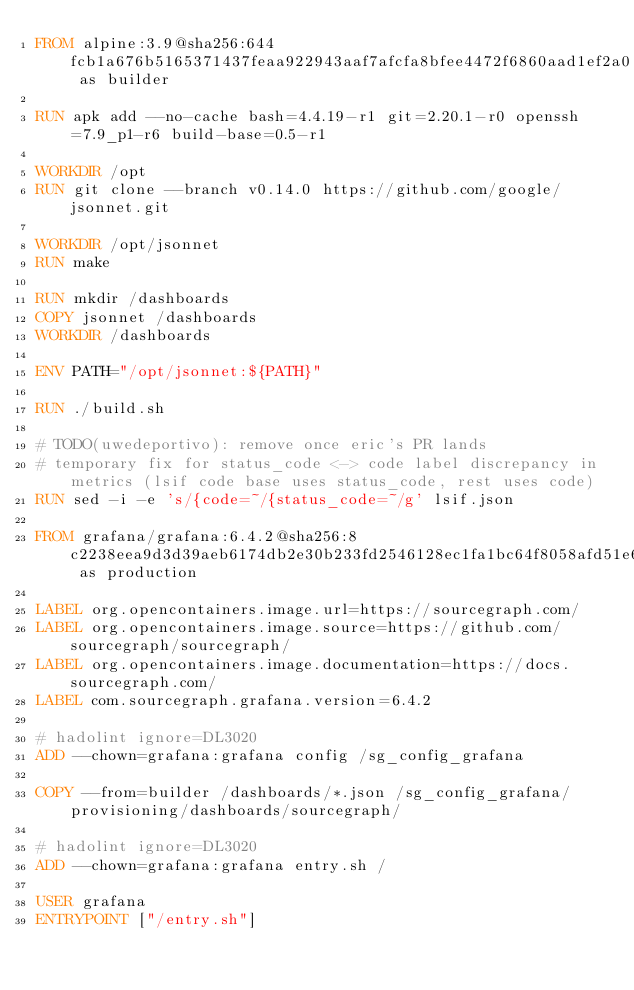Convert code to text. <code><loc_0><loc_0><loc_500><loc_500><_Dockerfile_>FROM alpine:3.9@sha256:644fcb1a676b5165371437feaa922943aaf7afcfa8bfee4472f6860aad1ef2a0 as builder

RUN apk add --no-cache bash=4.4.19-r1 git=2.20.1-r0 openssh=7.9_p1-r6 build-base=0.5-r1

WORKDIR /opt
RUN git clone --branch v0.14.0 https://github.com/google/jsonnet.git

WORKDIR /opt/jsonnet
RUN make

RUN mkdir /dashboards
COPY jsonnet /dashboards
WORKDIR /dashboards

ENV PATH="/opt/jsonnet:${PATH}"

RUN ./build.sh

# TODO(uwedeportivo): remove once eric's PR lands
# temporary fix for status_code <-> code label discrepancy in metrics (lsif code base uses status_code, rest uses code)
RUN sed -i -e 's/{code=~/{status_code=~/g' lsif.json

FROM grafana/grafana:6.4.2@sha256:8c2238eea9d3d39aeb6174db2e30b233fd2546128ec1fa1bc64f8058afd51e68 as production

LABEL org.opencontainers.image.url=https://sourcegraph.com/
LABEL org.opencontainers.image.source=https://github.com/sourcegraph/sourcegraph/
LABEL org.opencontainers.image.documentation=https://docs.sourcegraph.com/
LABEL com.sourcegraph.grafana.version=6.4.2

# hadolint ignore=DL3020
ADD --chown=grafana:grafana config /sg_config_grafana

COPY --from=builder /dashboards/*.json /sg_config_grafana/provisioning/dashboards/sourcegraph/

# hadolint ignore=DL3020
ADD --chown=grafana:grafana entry.sh /

USER grafana
ENTRYPOINT ["/entry.sh"]
</code> 